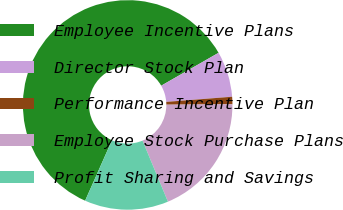Convert chart to OTSL. <chart><loc_0><loc_0><loc_500><loc_500><pie_chart><fcel>Employee Incentive Plans<fcel>Director Stock Plan<fcel>Performance Incentive Plan<fcel>Employee Stock Purchase Plans<fcel>Profit Sharing and Savings<nl><fcel>60.06%<fcel>7.04%<fcel>1.15%<fcel>18.82%<fcel>12.93%<nl></chart> 